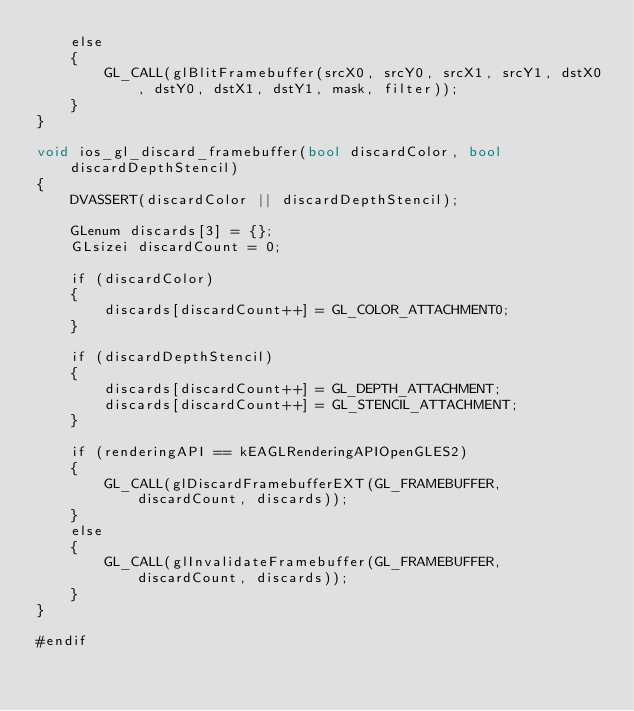<code> <loc_0><loc_0><loc_500><loc_500><_ObjectiveC_>    else
    {
        GL_CALL(glBlitFramebuffer(srcX0, srcY0, srcX1, srcY1, dstX0, dstY0, dstX1, dstY1, mask, filter));
    }
}

void ios_gl_discard_framebuffer(bool discardColor, bool discardDepthStencil)
{
    DVASSERT(discardColor || discardDepthStencil);

    GLenum discards[3] = {};
    GLsizei discardCount = 0;

    if (discardColor)
    {
        discards[discardCount++] = GL_COLOR_ATTACHMENT0;
    }

    if (discardDepthStencil)
    {
        discards[discardCount++] = GL_DEPTH_ATTACHMENT;
        discards[discardCount++] = GL_STENCIL_ATTACHMENT;
    }

    if (renderingAPI == kEAGLRenderingAPIOpenGLES2)
    {
        GL_CALL(glDiscardFramebufferEXT(GL_FRAMEBUFFER, discardCount, discards));
    }
    else
    {
        GL_CALL(glInvalidateFramebuffer(GL_FRAMEBUFFER, discardCount, discards));
    }
}

#endif
</code> 